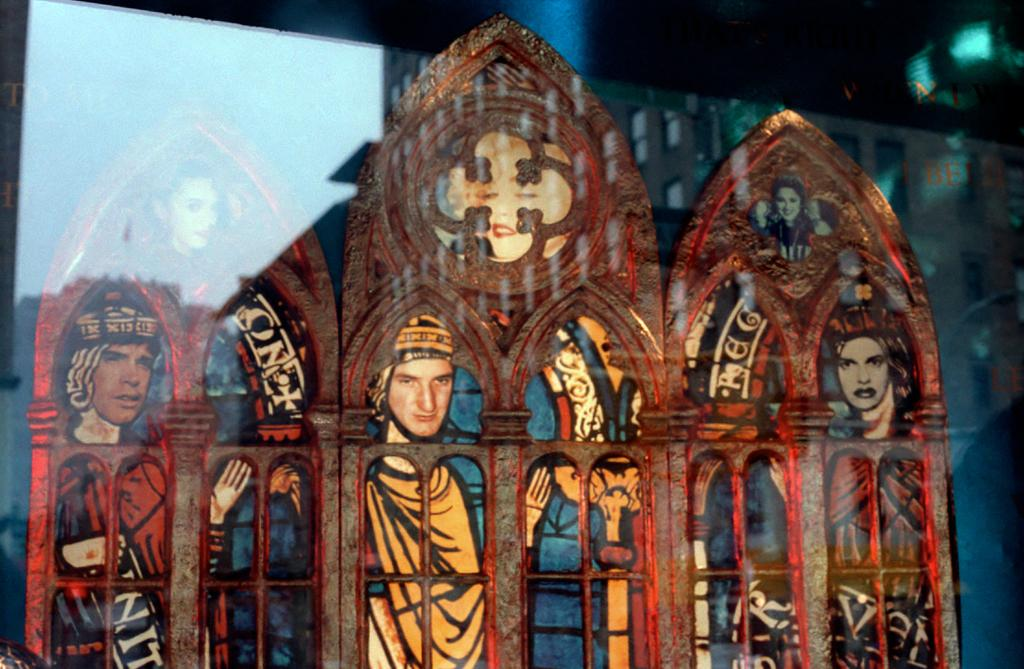What type of artwork is present in the image? There is a stained glass in the image. What is depicted in the stained glass? The stained glass contains a depiction of some persons. What type of oil is used in the stained glass? There is no mention of oil or any other materials used in the stained glass in the image. 